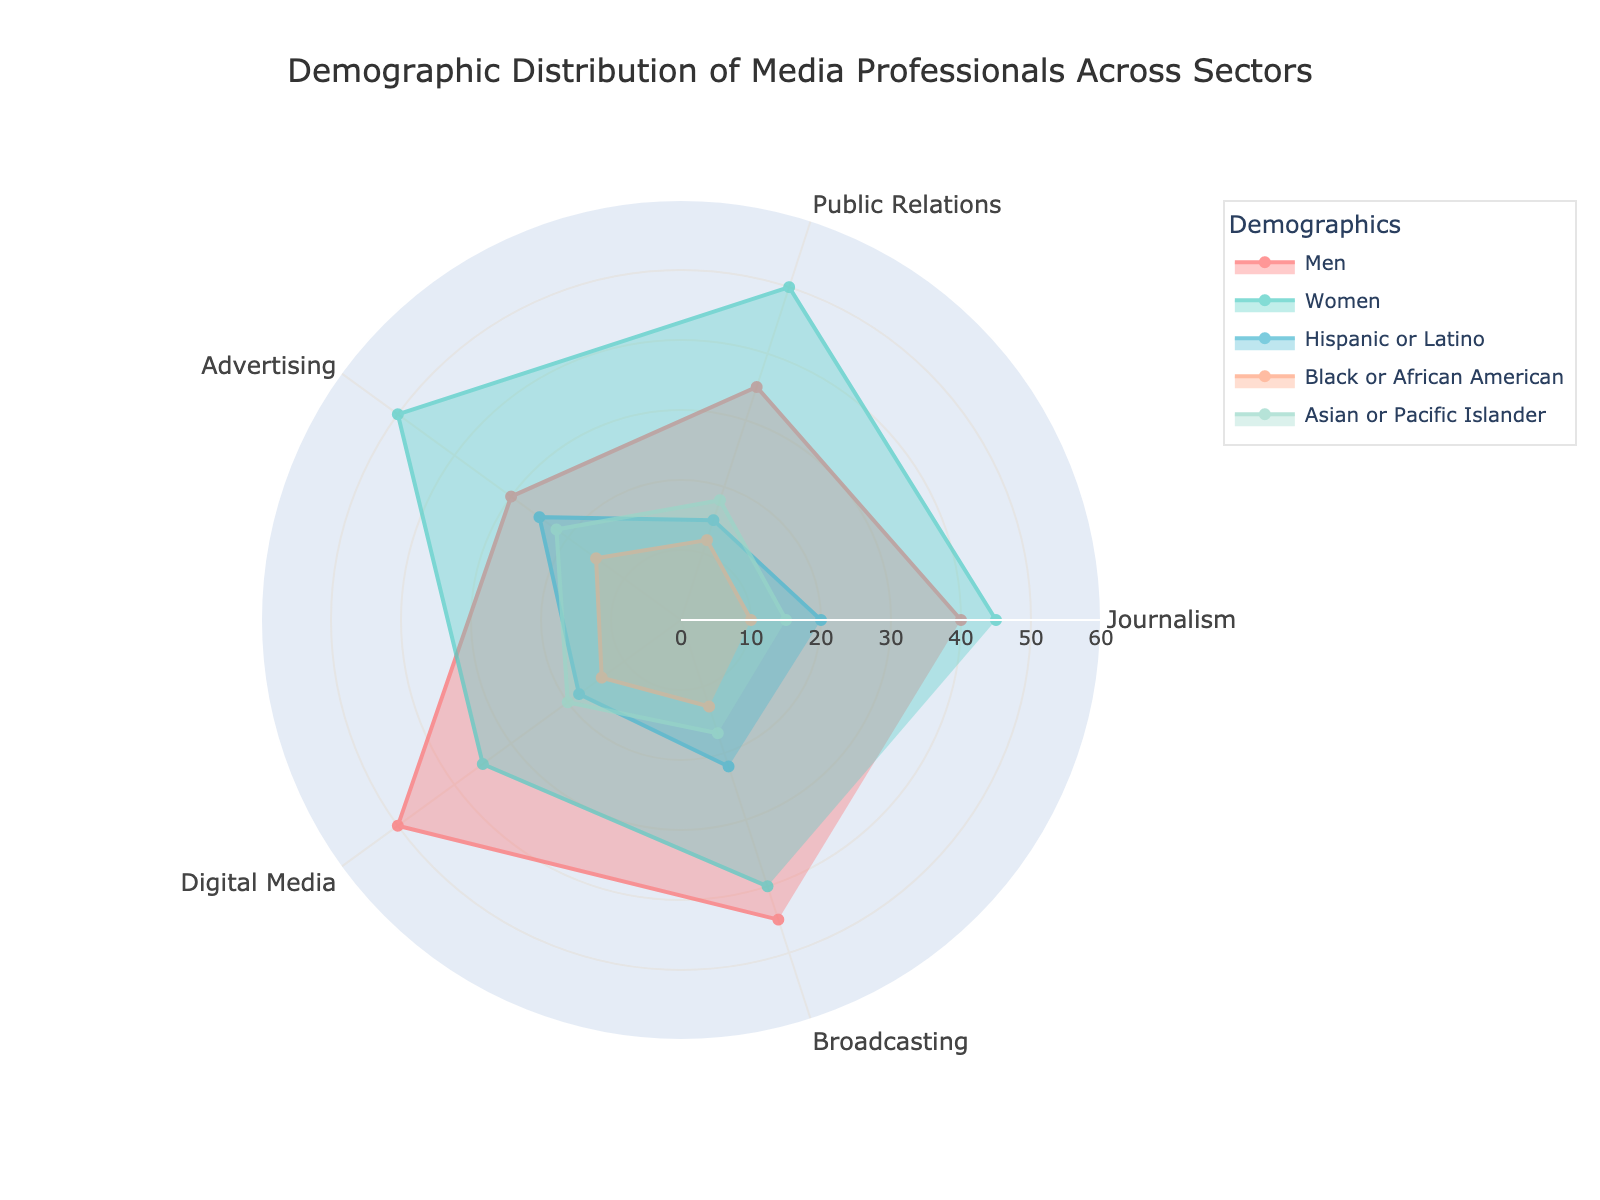What sectors are included in the radar chart? The radar chart includes the following sectors: Journalism, Public Relations, Advertising, Digital Media, and Broadcasting. This information can be confirmed by looking at the labels on the chart's theta axis.
Answer: Journalism, Public Relations, Advertising, Digital Media, Broadcasting Which sector has the highest percentage of men? To find the sector with the highest percentage of men, locate the 'Men' series and identify the sector with the maximum radial distance. The 'Men' series is easily identifiable with a specific color in the legend. By following this, we see that Digital Media has the highest percentage.
Answer: Digital Media What is the difference in the percentage of women between Public Relations and Digital Media sectors? Identify the percentages of women in the Public Relations (50) and Digital Media (35) sectors from the field representing women. Subtract the percentage of women in Digital Media from the percentage in Public Relations: 50 - 35 = 15.
Answer: 15 Which sector has the least representation of Black or African American professionals? To find this, locate the 'Black or African American' series on the radar chart and identify the sector with the smallest radial distance. According to the chart, Journalism has the least representation of Black or African American professionals, with a value of 10.
Answer: Journalism How does the representation of Asian or Pacific Islander professionals compare between Advertising and Broadcasting? Locate the percentages of Asian or Pacific Islander professionals for both Advertising (22) and Broadcasting (17) sectors using the corresponding color for this demographic. Compare both values to note that Advertising has a higher representation than Broadcasting.
Answer: Advertising > Broadcasting What is the average percentage of Hispanic or Latino professionals across all sectors? First, locate the percentages for Hispanic or Latino professionals across all sectors: Journalism (20), Public Relations (15), Advertising (25), Digital Media (18), and Broadcasting (22). Calculate the average by summing these values: 20 + 15 + 25 + 18 + 22 = 100, then divide by the number of sectors: 100/5 = 20.
Answer: 20 What demographic category appears to be the most equally distributed across different sectors? Examine the patterns of each demographic in the radar chart; an evenly distributed category will have similar radial distances across sectors. Women appear to have the most similar values across the sectors, with values consistently around 35-50 across all sectors.
Answer: Women Which sector shows the maximum diversity in terms of demographic distribution? Assess the radial spread of all demographic categories for each sector. Digital Media shows the widest variance, with men (50), women (35), Hispanic or Latino (18), Black or African American (14), and Asian or Pacific Islander (20), indicating a broad range of demographic values.
Answer: Digital Media Is the percentage of women in the Broadcasting sector higher or lower compared to the percentage of men in Journalism? Locate the data points for women in Broadcasting (40) and men in Journalism (40). Since both values are equal, the two categories have the same percentage in these sectors.
Answer: Equal Which sector has a higher representation of Hispanic or Latino professionals compared to Black or African American professionals? Compare the percentages of Hispanic or Latino professionals to Black or African American professionals within the same sector. For instance, in Advertising, 25% are Hispanic or Latino while 15% are Black or African American, making Advertising one such sector.
Answer: Advertising 